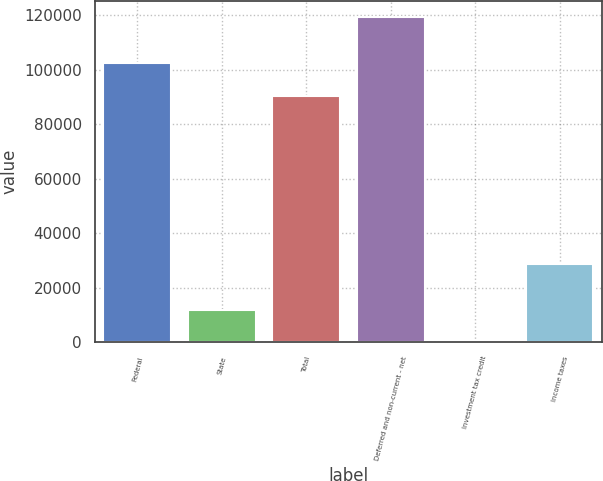Convert chart to OTSL. <chart><loc_0><loc_0><loc_500><loc_500><bar_chart><fcel>Federal<fcel>State<fcel>Total<fcel>Deferred and non-current - net<fcel>Investment tax credit<fcel>Income taxes<nl><fcel>102422<fcel>12059.6<fcel>90501<fcel>119345<fcel>139<fcel>28705<nl></chart> 